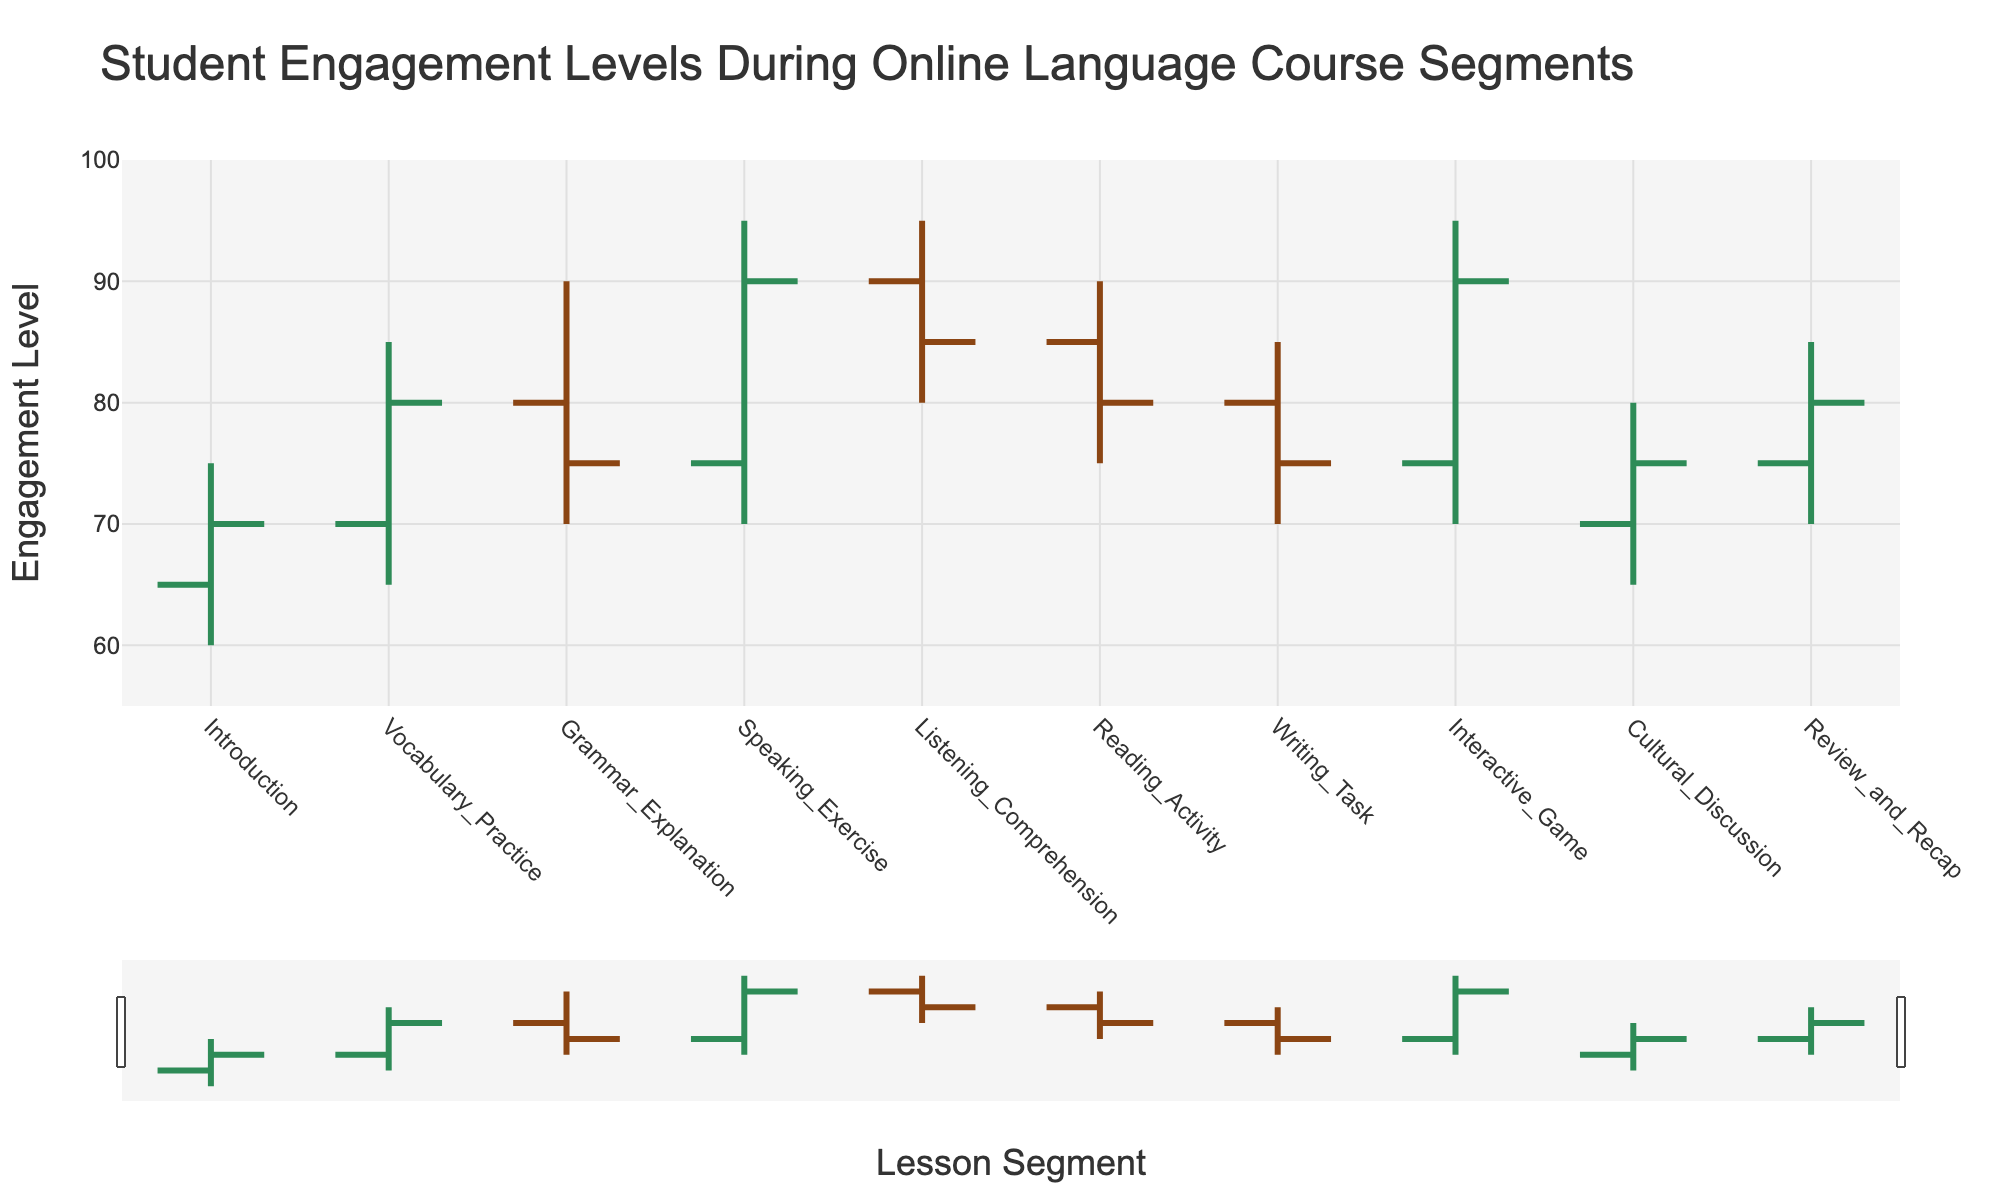what is the y-axis title of the plot? The figure shows a plot with labeled axes, and the y-axis title is visible above the numeric values marking the engagement levels, where it reads 'Engagement Level'.
Answer: Engagement Level What happens to the engagement level in the speaking exercise segment? In the Speaking Exercise segment, the engagement level opens at 75, reaches a high of 95, goes as low as 70, and closes at 90. The engagement level increases overall from the open to the close value.
Answer: It increases Which lesson segment has the highest closing engagement level? By examining the closing values (the right-side mark of each bar), Listing Comprehension, at 85, has the highest closing engagement level.
Answer: Listening Comprehension Compare the high points of Vocabulary Practice and Reading activity segments. The maximum value of Vocabulary Practice (85) is clearly higher than that of Reading Activity (90).
Answer: Reading Activity is higher During which segment is the largest fluctuation in engagement observed? The fluctuation for each segment is determined by the difference between the high and low values. The Speaking Exercise segment has a fluctuation range of 25, the largest compared to other segments.
Answer: Speaking Exercise How does the engagement level change from the introduction to interactive game segments? The Open value in the Introduction is 65, and it spikes to an Open value of 75 in the Interactive Game, showing an increasing trend in the engagement level.
Answer: It increases What are the engagement values of the cultural discussion segment? Look at the Cultural Discussion bar. Engagement opens at 70, peaks at 80, dips to 65, and closes at 75.
Answer: Open 70, High 80, Low 65, Close 75 Which segment shows a decrease in engagement from open to close, and by how much? The Grammar Explanation segment starts with an open of 80 and drops to a close of 75. Therefore, the decrease is 80 - 75 = 5.
Answer: Grammar Explanation, 5 What is the engagement range in the review and recap segment? The range is calculated by subtracting the low value from the high value. In Review and Recap, the range is 85 - 70 = 15.
Answer: 15 